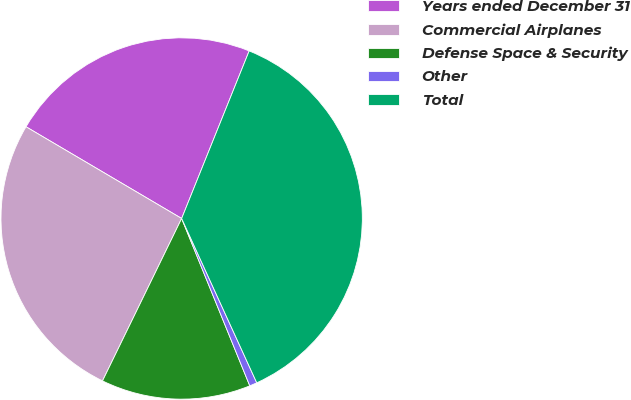Convert chart to OTSL. <chart><loc_0><loc_0><loc_500><loc_500><pie_chart><fcel>Years ended December 31<fcel>Commercial Airplanes<fcel>Defense Space & Security<fcel>Other<fcel>Total<nl><fcel>22.62%<fcel>26.26%<fcel>13.37%<fcel>0.67%<fcel>37.08%<nl></chart> 